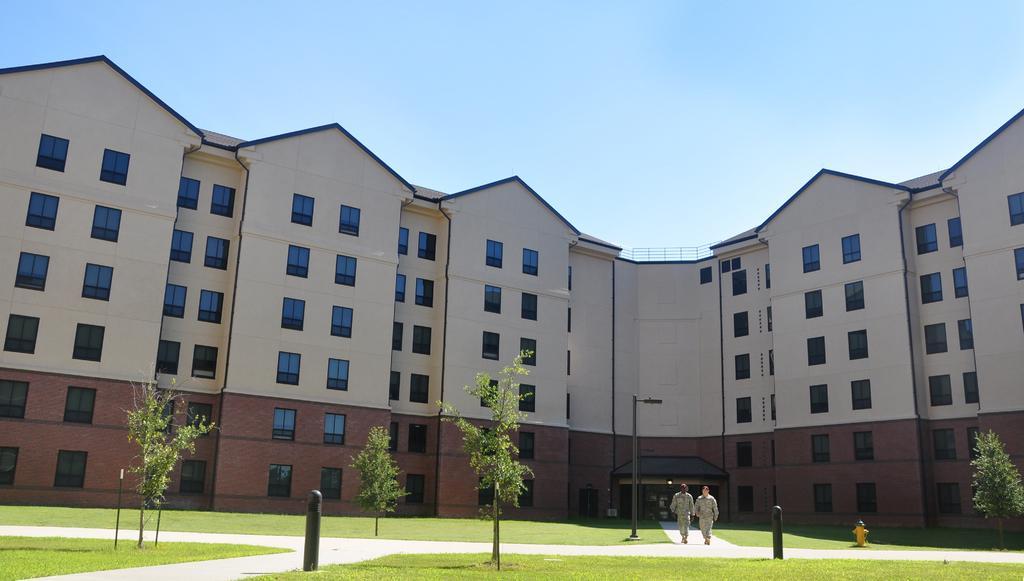Describe this image in one or two sentences. In this picture I can see some buildings, trees, grass and two persons are walking on the path. 